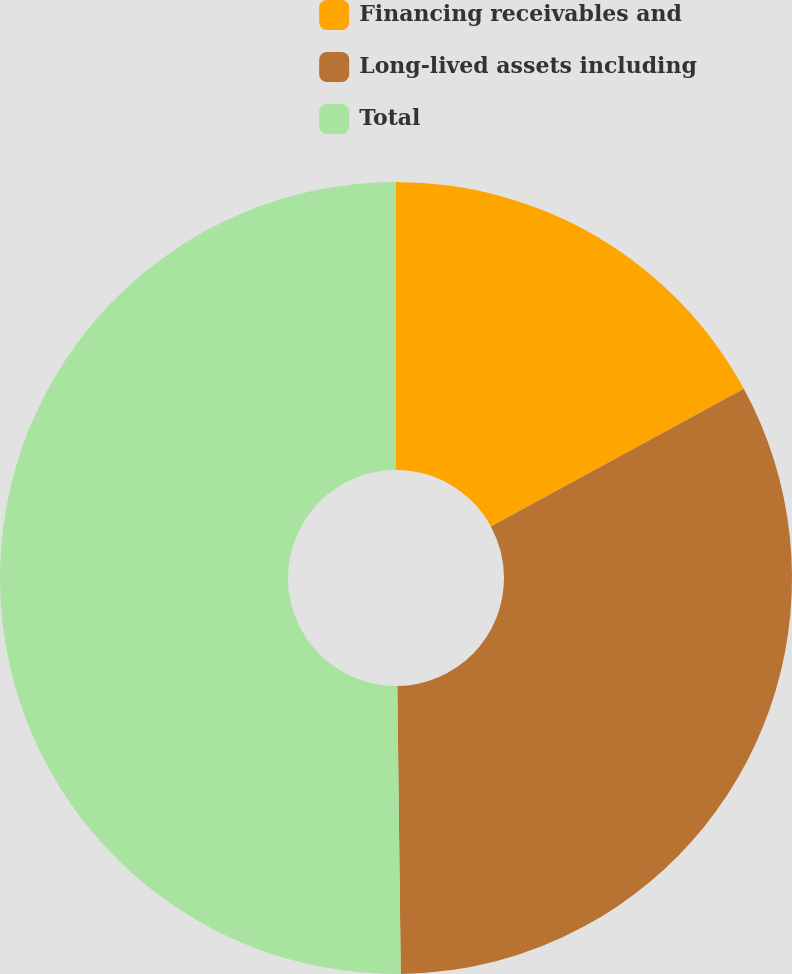Convert chart to OTSL. <chart><loc_0><loc_0><loc_500><loc_500><pie_chart><fcel>Financing receivables and<fcel>Long-lived assets including<fcel>Total<nl><fcel>17.07%<fcel>32.74%<fcel>50.19%<nl></chart> 